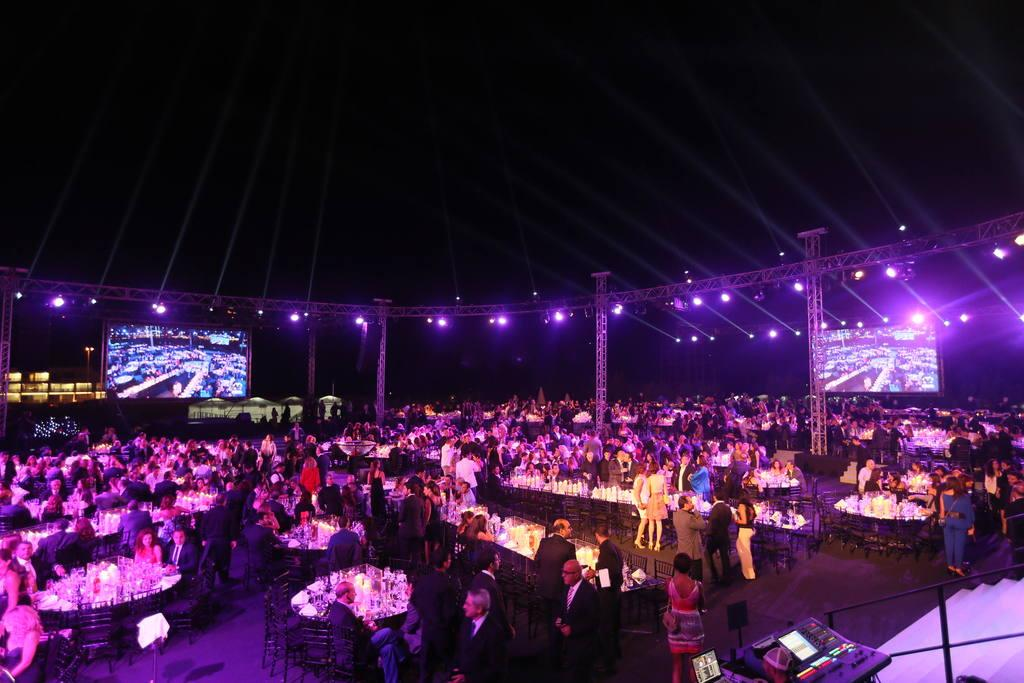How many people are in the image? There is a group of people in the image, but the exact number cannot be determined from the provided facts. What type of furniture is present in the image? There are tables and chairs in the image. What can be seen on the right side of the image? There is a staircase on the right side of the image. What type of electronic device is in the image? There is a screen in the image. What type of lighting is present in the image? There are lights in the image. What type of audio equipment is in the image? There is a music system in the image. What type of leather is used to make the waste container in the image? There is no waste container present in the image, and therefore no leather can be associated with it. What is the heart rate of the person in the image? There is no information about a person's heart rate in the image, and therefore it cannot be determined. 